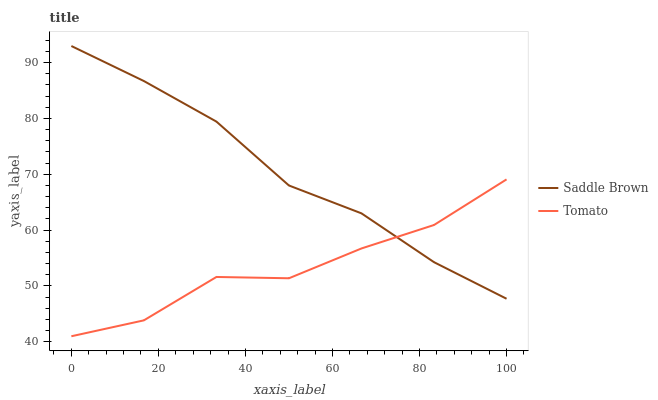Does Tomato have the minimum area under the curve?
Answer yes or no. Yes. Does Saddle Brown have the maximum area under the curve?
Answer yes or no. Yes. Does Saddle Brown have the minimum area under the curve?
Answer yes or no. No. Is Saddle Brown the smoothest?
Answer yes or no. Yes. Is Tomato the roughest?
Answer yes or no. Yes. Is Saddle Brown the roughest?
Answer yes or no. No. Does Tomato have the lowest value?
Answer yes or no. Yes. Does Saddle Brown have the lowest value?
Answer yes or no. No. Does Saddle Brown have the highest value?
Answer yes or no. Yes. Does Tomato intersect Saddle Brown?
Answer yes or no. Yes. Is Tomato less than Saddle Brown?
Answer yes or no. No. Is Tomato greater than Saddle Brown?
Answer yes or no. No. 